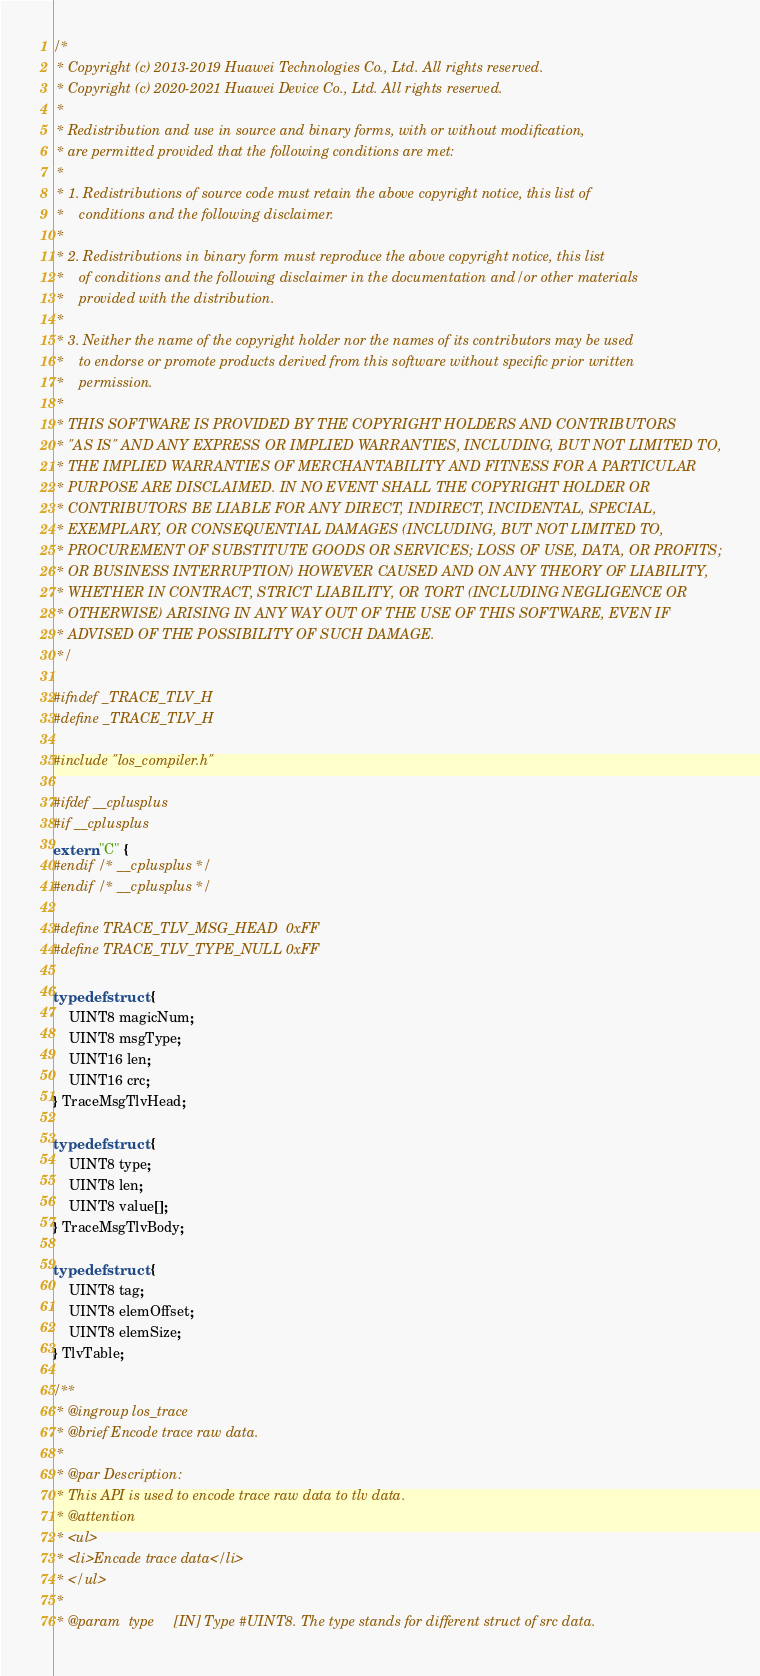Convert code to text. <code><loc_0><loc_0><loc_500><loc_500><_C_>/*
 * Copyright (c) 2013-2019 Huawei Technologies Co., Ltd. All rights reserved.
 * Copyright (c) 2020-2021 Huawei Device Co., Ltd. All rights reserved.
 *
 * Redistribution and use in source and binary forms, with or without modification,
 * are permitted provided that the following conditions are met:
 *
 * 1. Redistributions of source code must retain the above copyright notice, this list of
 *    conditions and the following disclaimer.
 *
 * 2. Redistributions in binary form must reproduce the above copyright notice, this list
 *    of conditions and the following disclaimer in the documentation and/or other materials
 *    provided with the distribution.
 *
 * 3. Neither the name of the copyright holder nor the names of its contributors may be used
 *    to endorse or promote products derived from this software without specific prior written
 *    permission.
 *
 * THIS SOFTWARE IS PROVIDED BY THE COPYRIGHT HOLDERS AND CONTRIBUTORS
 * "AS IS" AND ANY EXPRESS OR IMPLIED WARRANTIES, INCLUDING, BUT NOT LIMITED TO,
 * THE IMPLIED WARRANTIES OF MERCHANTABILITY AND FITNESS FOR A PARTICULAR
 * PURPOSE ARE DISCLAIMED. IN NO EVENT SHALL THE COPYRIGHT HOLDER OR
 * CONTRIBUTORS BE LIABLE FOR ANY DIRECT, INDIRECT, INCIDENTAL, SPECIAL,
 * EXEMPLARY, OR CONSEQUENTIAL DAMAGES (INCLUDING, BUT NOT LIMITED TO,
 * PROCUREMENT OF SUBSTITUTE GOODS OR SERVICES; LOSS OF USE, DATA, OR PROFITS;
 * OR BUSINESS INTERRUPTION) HOWEVER CAUSED AND ON ANY THEORY OF LIABILITY,
 * WHETHER IN CONTRACT, STRICT LIABILITY, OR TORT (INCLUDING NEGLIGENCE OR
 * OTHERWISE) ARISING IN ANY WAY OUT OF THE USE OF THIS SOFTWARE, EVEN IF
 * ADVISED OF THE POSSIBILITY OF SUCH DAMAGE.
 */

#ifndef _TRACE_TLV_H
#define _TRACE_TLV_H

#include "los_compiler.h"

#ifdef __cplusplus
#if __cplusplus
extern "C" {
#endif /* __cplusplus */
#endif /* __cplusplus */

#define TRACE_TLV_MSG_HEAD  0xFF
#define TRACE_TLV_TYPE_NULL 0xFF

typedef struct {
    UINT8 magicNum;
    UINT8 msgType;
    UINT16 len;
    UINT16 crc;
} TraceMsgTlvHead;

typedef struct {
    UINT8 type;
    UINT8 len;
    UINT8 value[];
} TraceMsgTlvBody;

typedef struct {
    UINT8 tag;
    UINT8 elemOffset;
    UINT8 elemSize;
} TlvTable;

/**
 * @ingroup los_trace
 * @brief Encode trace raw data.
 *
 * @par Description:
 * This API is used to encode trace raw data to tlv data.
 * @attention
 * <ul>
 * <li>Encade trace data</li>
 * </ul>
 *
 * @param  type     [IN] Type #UINT8. The type stands for different struct of src data.</code> 